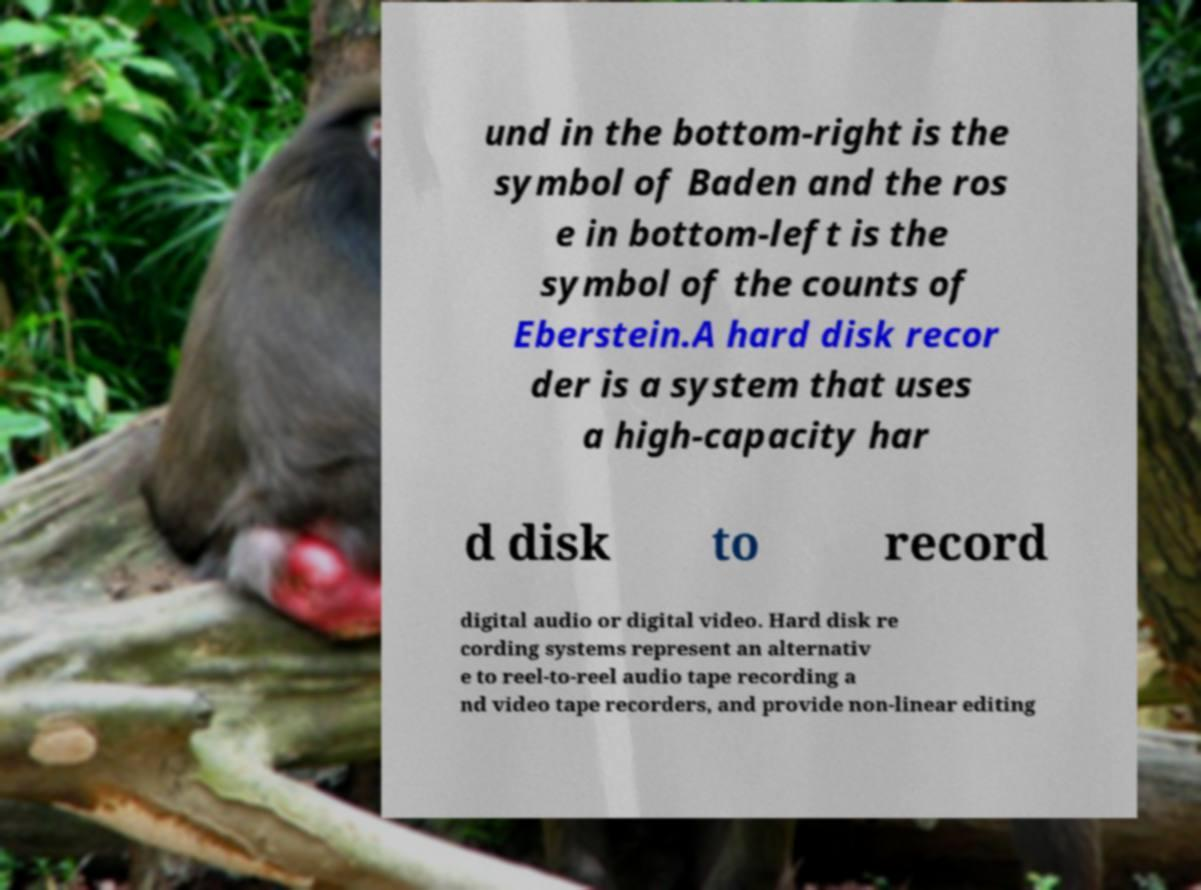Can you accurately transcribe the text from the provided image for me? und in the bottom-right is the symbol of Baden and the ros e in bottom-left is the symbol of the counts of Eberstein.A hard disk recor der is a system that uses a high-capacity har d disk to record digital audio or digital video. Hard disk re cording systems represent an alternativ e to reel-to-reel audio tape recording a nd video tape recorders, and provide non-linear editing 